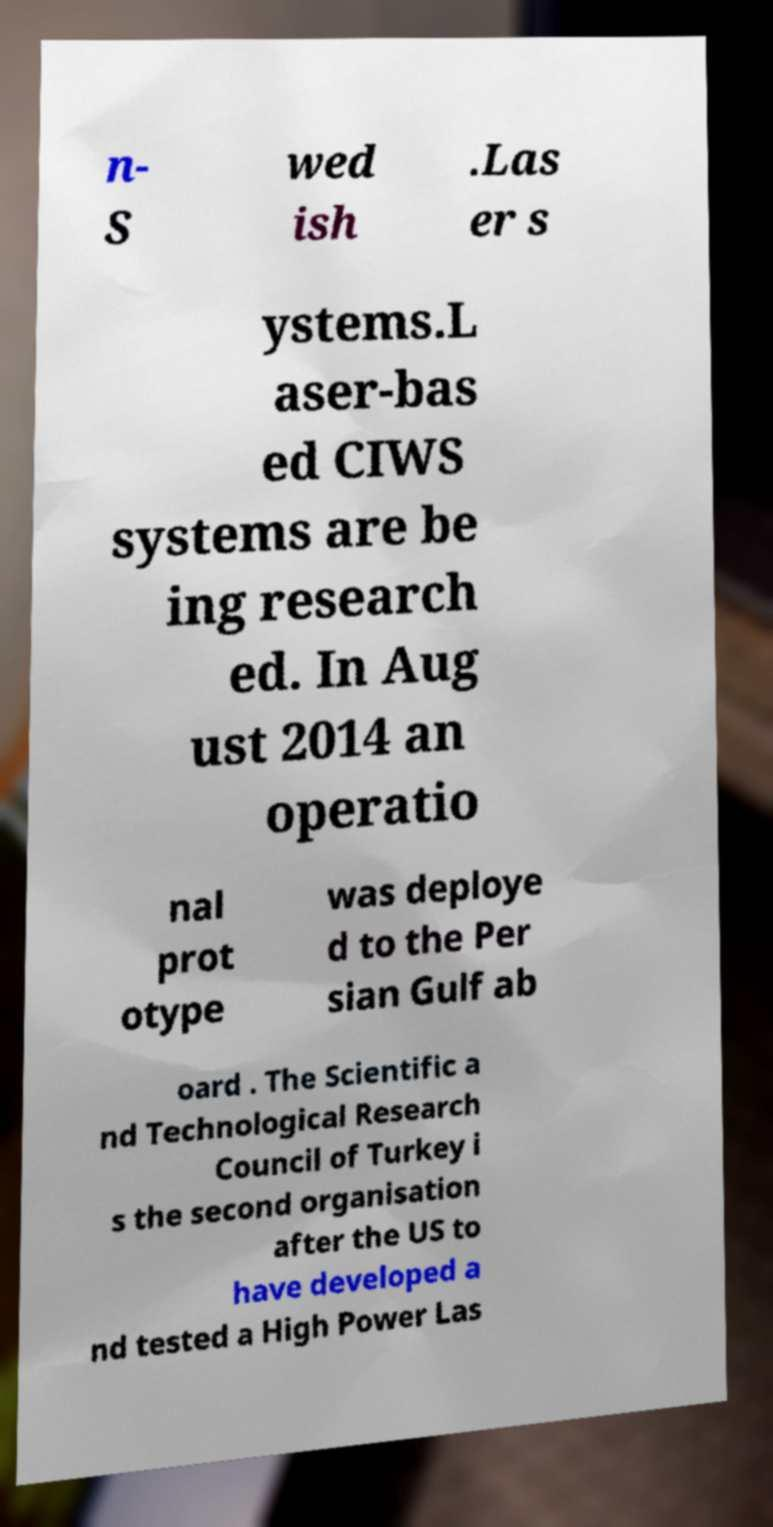There's text embedded in this image that I need extracted. Can you transcribe it verbatim? n- S wed ish .Las er s ystems.L aser-bas ed CIWS systems are be ing research ed. In Aug ust 2014 an operatio nal prot otype was deploye d to the Per sian Gulf ab oard . The Scientific a nd Technological Research Council of Turkey i s the second organisation after the US to have developed a nd tested a High Power Las 